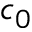Convert formula to latex. <formula><loc_0><loc_0><loc_500><loc_500>c _ { 0 }</formula> 